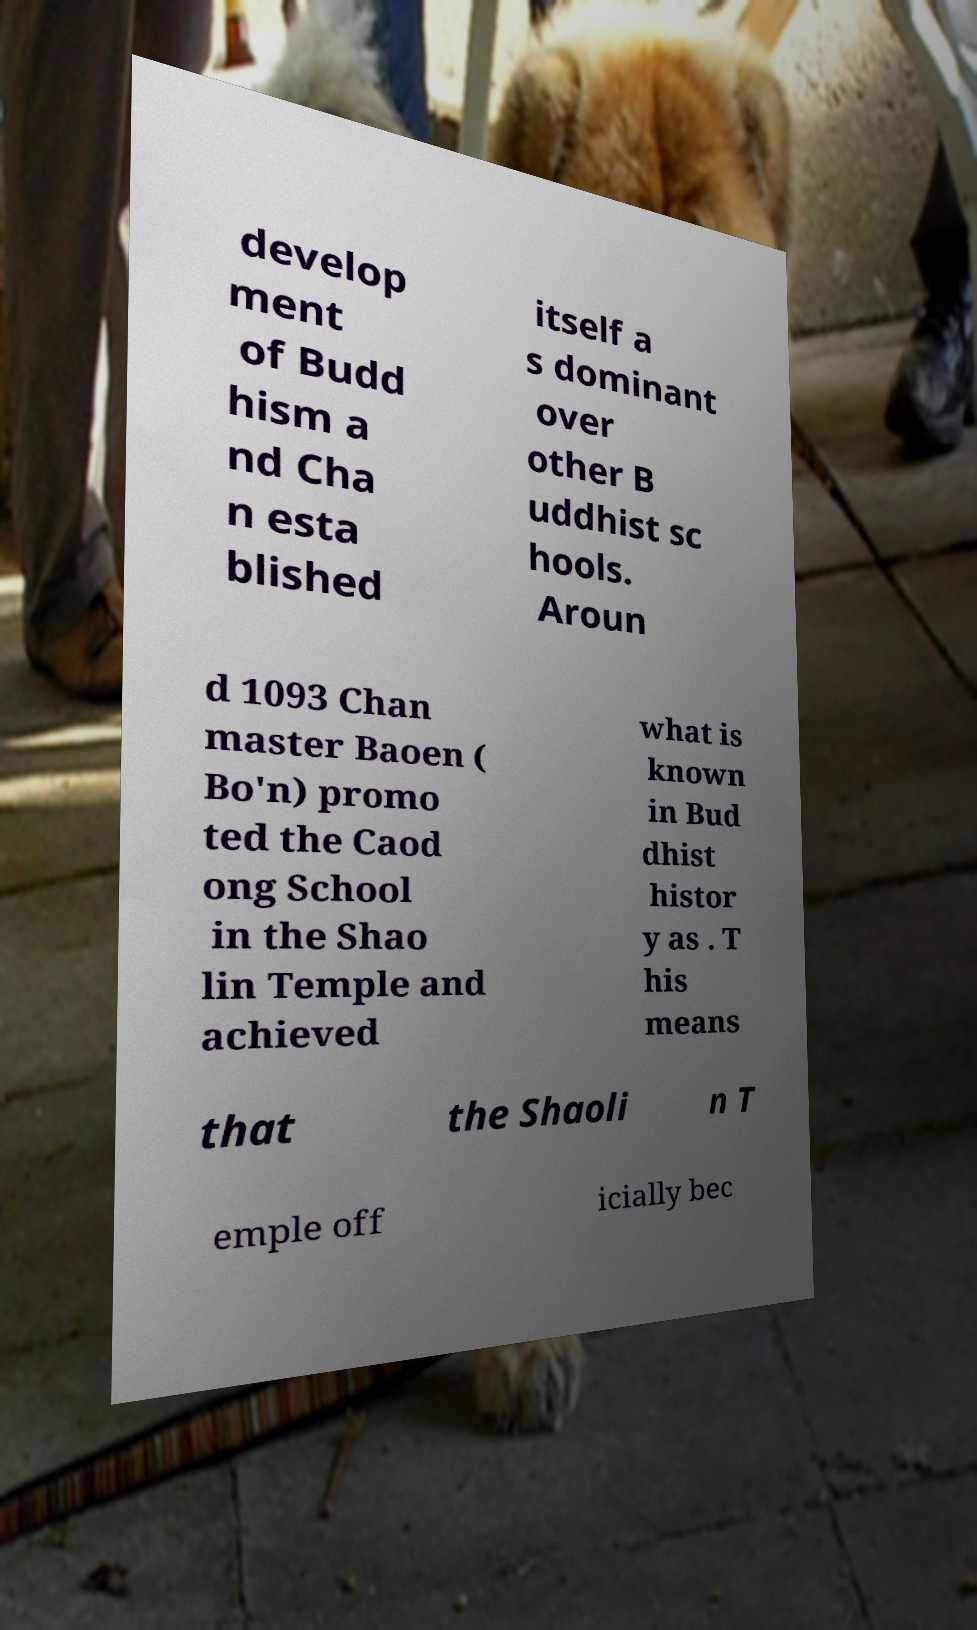Could you assist in decoding the text presented in this image and type it out clearly? develop ment of Budd hism a nd Cha n esta blished itself a s dominant over other B uddhist sc hools. Aroun d 1093 Chan master Baoen ( Bo'n) promo ted the Caod ong School in the Shao lin Temple and achieved what is known in Bud dhist histor y as . T his means that the Shaoli n T emple off icially bec 